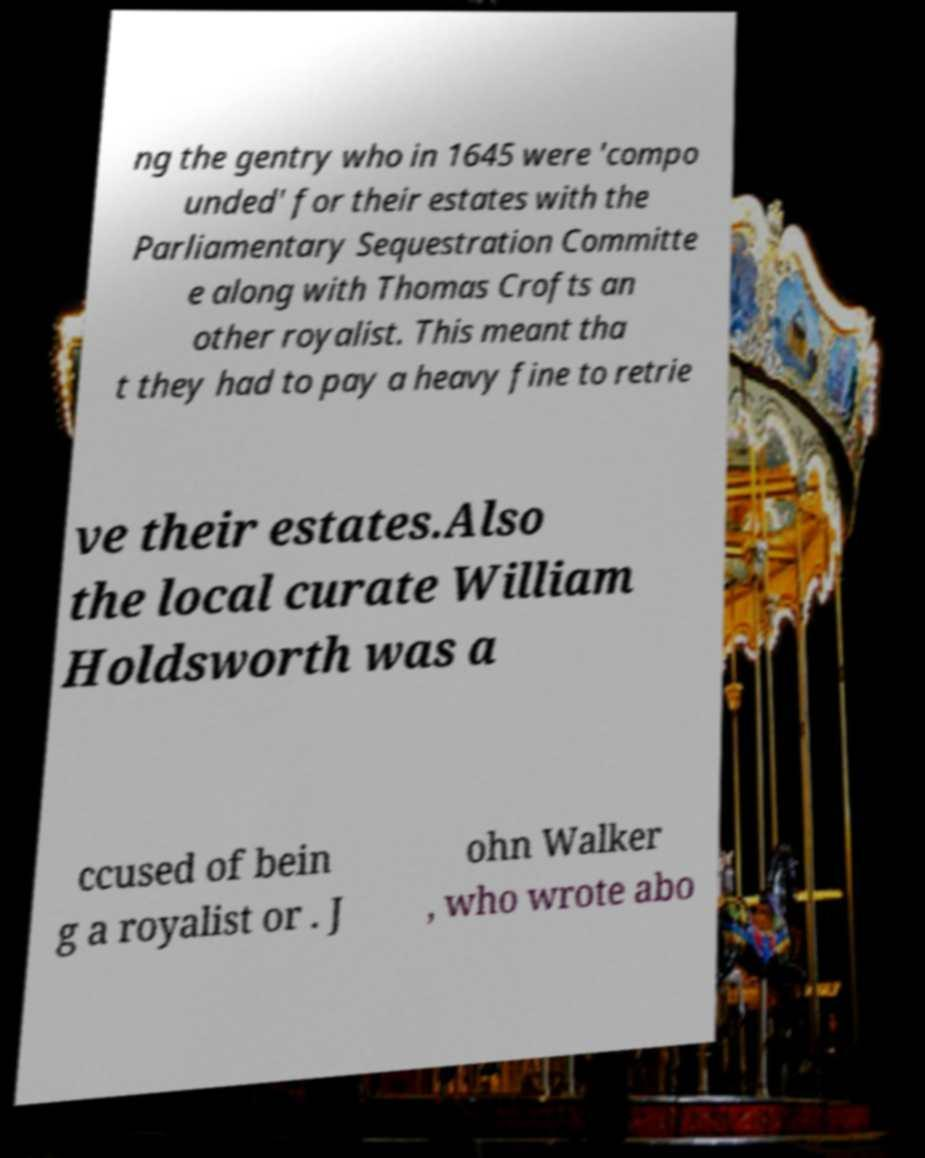Can you accurately transcribe the text from the provided image for me? ng the gentry who in 1645 were 'compo unded' for their estates with the Parliamentary Sequestration Committe e along with Thomas Crofts an other royalist. This meant tha t they had to pay a heavy fine to retrie ve their estates.Also the local curate William Holdsworth was a ccused of bein g a royalist or . J ohn Walker , who wrote abo 